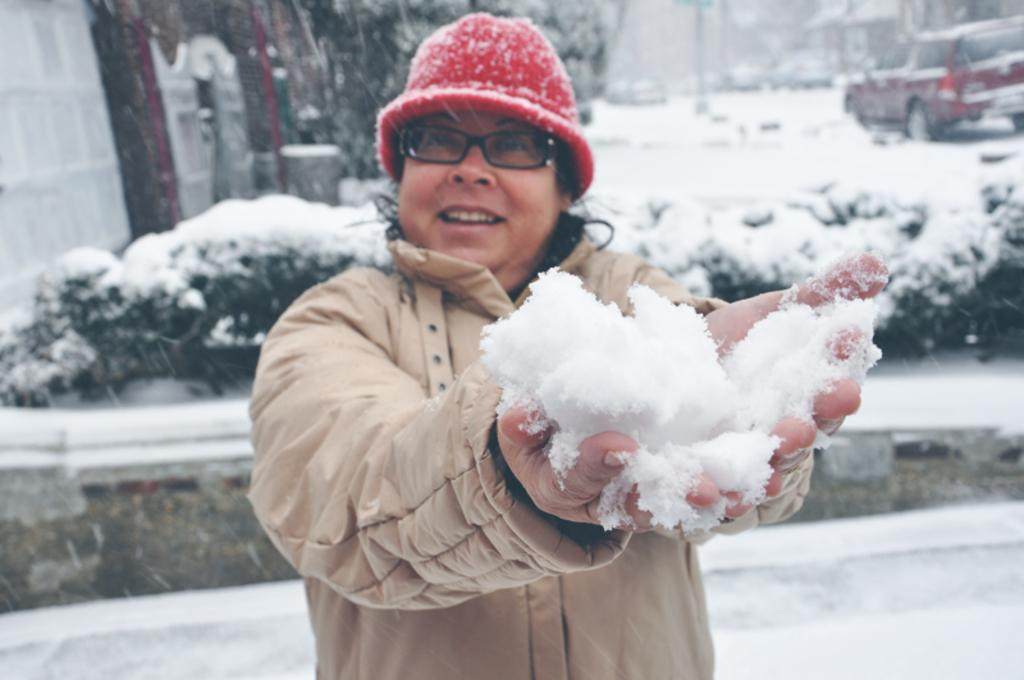What is the person in the image doing? The person is standing in the image and holding snow in their hands. What can be seen in the background of the image? There are motor vehicles, buildings, and bushes visible in the background. What is the condition of the ground in the image? The ground is covered with snow. What type of calculator is the person using to measure the snow in the image? There is no calculator present in the image, and the person is not measuring the snow. 